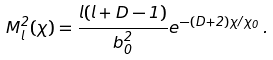Convert formula to latex. <formula><loc_0><loc_0><loc_500><loc_500>M _ { l } ^ { 2 } ( \chi ) = \frac { l ( l + D - 1 ) } { b _ { 0 } ^ { 2 } } e ^ { - ( D + 2 ) \chi / \chi _ { 0 } } \, .</formula> 